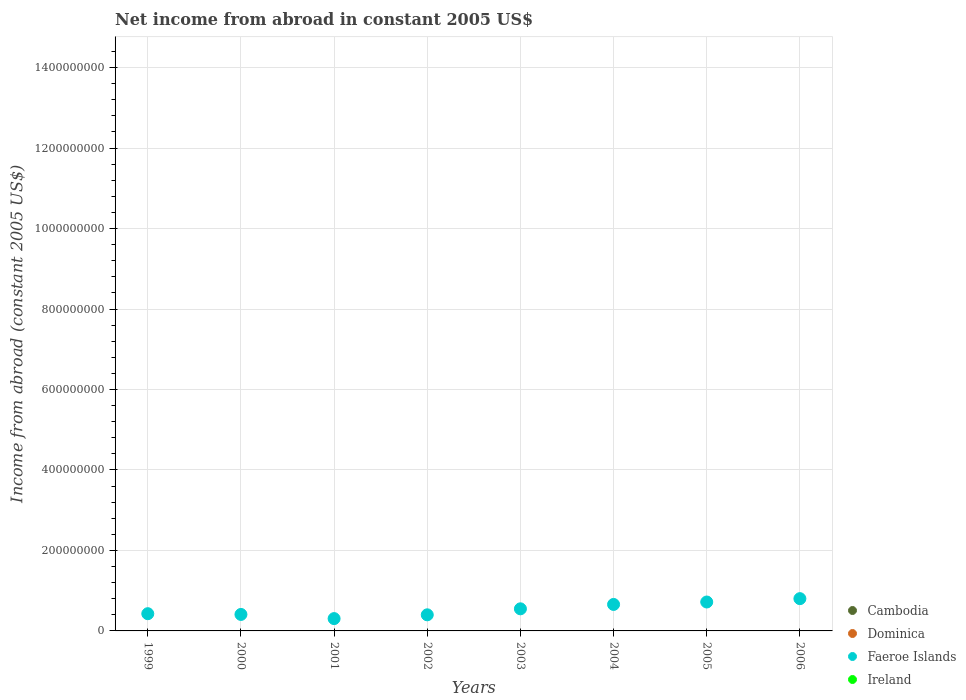What is the net income from abroad in Dominica in 2000?
Offer a very short reply. 0. Across all years, what is the maximum net income from abroad in Faeroe Islands?
Offer a terse response. 8.02e+07. Across all years, what is the minimum net income from abroad in Ireland?
Give a very brief answer. 0. In which year was the net income from abroad in Faeroe Islands maximum?
Provide a short and direct response. 2006. What is the difference between the net income from abroad in Faeroe Islands in 2001 and that in 2003?
Provide a short and direct response. -2.43e+07. What is the difference between the net income from abroad in Faeroe Islands in 2004 and the net income from abroad in Ireland in 2003?
Provide a succinct answer. 6.58e+07. In how many years, is the net income from abroad in Cambodia greater than 1320000000 US$?
Offer a very short reply. 0. What is the ratio of the net income from abroad in Faeroe Islands in 2002 to that in 2006?
Your response must be concise. 0.5. What is the difference between the highest and the second highest net income from abroad in Faeroe Islands?
Provide a succinct answer. 8.34e+06. In how many years, is the net income from abroad in Ireland greater than the average net income from abroad in Ireland taken over all years?
Make the answer very short. 0. Does the net income from abroad in Dominica monotonically increase over the years?
Your answer should be compact. No. Is the net income from abroad in Ireland strictly less than the net income from abroad in Faeroe Islands over the years?
Your response must be concise. Yes. How many dotlines are there?
Your answer should be compact. 1. Where does the legend appear in the graph?
Offer a terse response. Bottom right. How are the legend labels stacked?
Provide a short and direct response. Vertical. What is the title of the graph?
Your response must be concise. Net income from abroad in constant 2005 US$. What is the label or title of the X-axis?
Give a very brief answer. Years. What is the label or title of the Y-axis?
Offer a very short reply. Income from abroad (constant 2005 US$). What is the Income from abroad (constant 2005 US$) in Dominica in 1999?
Keep it short and to the point. 0. What is the Income from abroad (constant 2005 US$) in Faeroe Islands in 1999?
Offer a terse response. 4.28e+07. What is the Income from abroad (constant 2005 US$) in Faeroe Islands in 2000?
Provide a succinct answer. 4.10e+07. What is the Income from abroad (constant 2005 US$) of Faeroe Islands in 2001?
Make the answer very short. 3.06e+07. What is the Income from abroad (constant 2005 US$) of Ireland in 2001?
Keep it short and to the point. 0. What is the Income from abroad (constant 2005 US$) in Cambodia in 2002?
Offer a terse response. 0. What is the Income from abroad (constant 2005 US$) in Faeroe Islands in 2002?
Offer a terse response. 4.00e+07. What is the Income from abroad (constant 2005 US$) in Cambodia in 2003?
Make the answer very short. 0. What is the Income from abroad (constant 2005 US$) of Faeroe Islands in 2003?
Provide a short and direct response. 5.49e+07. What is the Income from abroad (constant 2005 US$) in Faeroe Islands in 2004?
Ensure brevity in your answer.  6.58e+07. What is the Income from abroad (constant 2005 US$) in Ireland in 2004?
Ensure brevity in your answer.  0. What is the Income from abroad (constant 2005 US$) of Cambodia in 2005?
Provide a succinct answer. 0. What is the Income from abroad (constant 2005 US$) in Faeroe Islands in 2005?
Provide a succinct answer. 7.19e+07. What is the Income from abroad (constant 2005 US$) of Faeroe Islands in 2006?
Your answer should be very brief. 8.02e+07. Across all years, what is the maximum Income from abroad (constant 2005 US$) of Faeroe Islands?
Provide a succinct answer. 8.02e+07. Across all years, what is the minimum Income from abroad (constant 2005 US$) of Faeroe Islands?
Your answer should be compact. 3.06e+07. What is the total Income from abroad (constant 2005 US$) in Faeroe Islands in the graph?
Your answer should be very brief. 4.27e+08. What is the total Income from abroad (constant 2005 US$) of Ireland in the graph?
Your answer should be compact. 0. What is the difference between the Income from abroad (constant 2005 US$) in Faeroe Islands in 1999 and that in 2000?
Make the answer very short. 1.84e+06. What is the difference between the Income from abroad (constant 2005 US$) of Faeroe Islands in 1999 and that in 2001?
Give a very brief answer. 1.22e+07. What is the difference between the Income from abroad (constant 2005 US$) of Faeroe Islands in 1999 and that in 2002?
Give a very brief answer. 2.78e+06. What is the difference between the Income from abroad (constant 2005 US$) of Faeroe Islands in 1999 and that in 2003?
Your answer should be compact. -1.21e+07. What is the difference between the Income from abroad (constant 2005 US$) in Faeroe Islands in 1999 and that in 2004?
Provide a succinct answer. -2.30e+07. What is the difference between the Income from abroad (constant 2005 US$) in Faeroe Islands in 1999 and that in 2005?
Your answer should be very brief. -2.91e+07. What is the difference between the Income from abroad (constant 2005 US$) in Faeroe Islands in 1999 and that in 2006?
Your response must be concise. -3.74e+07. What is the difference between the Income from abroad (constant 2005 US$) of Faeroe Islands in 2000 and that in 2001?
Offer a very short reply. 1.03e+07. What is the difference between the Income from abroad (constant 2005 US$) in Faeroe Islands in 2000 and that in 2002?
Your response must be concise. 9.35e+05. What is the difference between the Income from abroad (constant 2005 US$) of Faeroe Islands in 2000 and that in 2003?
Offer a terse response. -1.40e+07. What is the difference between the Income from abroad (constant 2005 US$) of Faeroe Islands in 2000 and that in 2004?
Offer a very short reply. -2.49e+07. What is the difference between the Income from abroad (constant 2005 US$) of Faeroe Islands in 2000 and that in 2005?
Your answer should be very brief. -3.09e+07. What is the difference between the Income from abroad (constant 2005 US$) of Faeroe Islands in 2000 and that in 2006?
Your response must be concise. -3.92e+07. What is the difference between the Income from abroad (constant 2005 US$) of Faeroe Islands in 2001 and that in 2002?
Keep it short and to the point. -9.40e+06. What is the difference between the Income from abroad (constant 2005 US$) in Faeroe Islands in 2001 and that in 2003?
Make the answer very short. -2.43e+07. What is the difference between the Income from abroad (constant 2005 US$) in Faeroe Islands in 2001 and that in 2004?
Ensure brevity in your answer.  -3.52e+07. What is the difference between the Income from abroad (constant 2005 US$) of Faeroe Islands in 2001 and that in 2005?
Give a very brief answer. -4.12e+07. What is the difference between the Income from abroad (constant 2005 US$) in Faeroe Islands in 2001 and that in 2006?
Provide a short and direct response. -4.96e+07. What is the difference between the Income from abroad (constant 2005 US$) in Faeroe Islands in 2002 and that in 2003?
Make the answer very short. -1.49e+07. What is the difference between the Income from abroad (constant 2005 US$) in Faeroe Islands in 2002 and that in 2004?
Your response must be concise. -2.58e+07. What is the difference between the Income from abroad (constant 2005 US$) in Faeroe Islands in 2002 and that in 2005?
Provide a short and direct response. -3.18e+07. What is the difference between the Income from abroad (constant 2005 US$) in Faeroe Islands in 2002 and that in 2006?
Your answer should be very brief. -4.02e+07. What is the difference between the Income from abroad (constant 2005 US$) in Faeroe Islands in 2003 and that in 2004?
Provide a succinct answer. -1.09e+07. What is the difference between the Income from abroad (constant 2005 US$) in Faeroe Islands in 2003 and that in 2005?
Give a very brief answer. -1.69e+07. What is the difference between the Income from abroad (constant 2005 US$) of Faeroe Islands in 2003 and that in 2006?
Make the answer very short. -2.53e+07. What is the difference between the Income from abroad (constant 2005 US$) of Faeroe Islands in 2004 and that in 2005?
Offer a very short reply. -6.06e+06. What is the difference between the Income from abroad (constant 2005 US$) in Faeroe Islands in 2004 and that in 2006?
Offer a terse response. -1.44e+07. What is the difference between the Income from abroad (constant 2005 US$) in Faeroe Islands in 2005 and that in 2006?
Your answer should be very brief. -8.34e+06. What is the average Income from abroad (constant 2005 US$) of Faeroe Islands per year?
Your answer should be compact. 5.34e+07. What is the average Income from abroad (constant 2005 US$) of Ireland per year?
Your response must be concise. 0. What is the ratio of the Income from abroad (constant 2005 US$) in Faeroe Islands in 1999 to that in 2000?
Make the answer very short. 1.04. What is the ratio of the Income from abroad (constant 2005 US$) of Faeroe Islands in 1999 to that in 2001?
Your answer should be very brief. 1.4. What is the ratio of the Income from abroad (constant 2005 US$) of Faeroe Islands in 1999 to that in 2002?
Ensure brevity in your answer.  1.07. What is the ratio of the Income from abroad (constant 2005 US$) of Faeroe Islands in 1999 to that in 2003?
Offer a very short reply. 0.78. What is the ratio of the Income from abroad (constant 2005 US$) in Faeroe Islands in 1999 to that in 2004?
Your response must be concise. 0.65. What is the ratio of the Income from abroad (constant 2005 US$) of Faeroe Islands in 1999 to that in 2005?
Keep it short and to the point. 0.6. What is the ratio of the Income from abroad (constant 2005 US$) of Faeroe Islands in 1999 to that in 2006?
Ensure brevity in your answer.  0.53. What is the ratio of the Income from abroad (constant 2005 US$) of Faeroe Islands in 2000 to that in 2001?
Give a very brief answer. 1.34. What is the ratio of the Income from abroad (constant 2005 US$) in Faeroe Islands in 2000 to that in 2002?
Your answer should be compact. 1.02. What is the ratio of the Income from abroad (constant 2005 US$) of Faeroe Islands in 2000 to that in 2003?
Provide a succinct answer. 0.75. What is the ratio of the Income from abroad (constant 2005 US$) of Faeroe Islands in 2000 to that in 2004?
Provide a succinct answer. 0.62. What is the ratio of the Income from abroad (constant 2005 US$) in Faeroe Islands in 2000 to that in 2005?
Provide a succinct answer. 0.57. What is the ratio of the Income from abroad (constant 2005 US$) of Faeroe Islands in 2000 to that in 2006?
Make the answer very short. 0.51. What is the ratio of the Income from abroad (constant 2005 US$) of Faeroe Islands in 2001 to that in 2002?
Your answer should be compact. 0.77. What is the ratio of the Income from abroad (constant 2005 US$) in Faeroe Islands in 2001 to that in 2003?
Your response must be concise. 0.56. What is the ratio of the Income from abroad (constant 2005 US$) in Faeroe Islands in 2001 to that in 2004?
Your answer should be very brief. 0.47. What is the ratio of the Income from abroad (constant 2005 US$) in Faeroe Islands in 2001 to that in 2005?
Provide a succinct answer. 0.43. What is the ratio of the Income from abroad (constant 2005 US$) in Faeroe Islands in 2001 to that in 2006?
Give a very brief answer. 0.38. What is the ratio of the Income from abroad (constant 2005 US$) of Faeroe Islands in 2002 to that in 2003?
Provide a short and direct response. 0.73. What is the ratio of the Income from abroad (constant 2005 US$) of Faeroe Islands in 2002 to that in 2004?
Your answer should be very brief. 0.61. What is the ratio of the Income from abroad (constant 2005 US$) of Faeroe Islands in 2002 to that in 2005?
Provide a short and direct response. 0.56. What is the ratio of the Income from abroad (constant 2005 US$) in Faeroe Islands in 2002 to that in 2006?
Offer a terse response. 0.5. What is the ratio of the Income from abroad (constant 2005 US$) of Faeroe Islands in 2003 to that in 2004?
Provide a short and direct response. 0.83. What is the ratio of the Income from abroad (constant 2005 US$) of Faeroe Islands in 2003 to that in 2005?
Keep it short and to the point. 0.76. What is the ratio of the Income from abroad (constant 2005 US$) in Faeroe Islands in 2003 to that in 2006?
Your response must be concise. 0.68. What is the ratio of the Income from abroad (constant 2005 US$) in Faeroe Islands in 2004 to that in 2005?
Give a very brief answer. 0.92. What is the ratio of the Income from abroad (constant 2005 US$) of Faeroe Islands in 2004 to that in 2006?
Give a very brief answer. 0.82. What is the ratio of the Income from abroad (constant 2005 US$) of Faeroe Islands in 2005 to that in 2006?
Your response must be concise. 0.9. What is the difference between the highest and the second highest Income from abroad (constant 2005 US$) of Faeroe Islands?
Your answer should be very brief. 8.34e+06. What is the difference between the highest and the lowest Income from abroad (constant 2005 US$) of Faeroe Islands?
Your answer should be compact. 4.96e+07. 